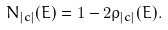Convert formula to latex. <formula><loc_0><loc_0><loc_500><loc_500>N _ { | c | } ( E ) = 1 - 2 \rho _ { | c | } ( E ) .</formula> 